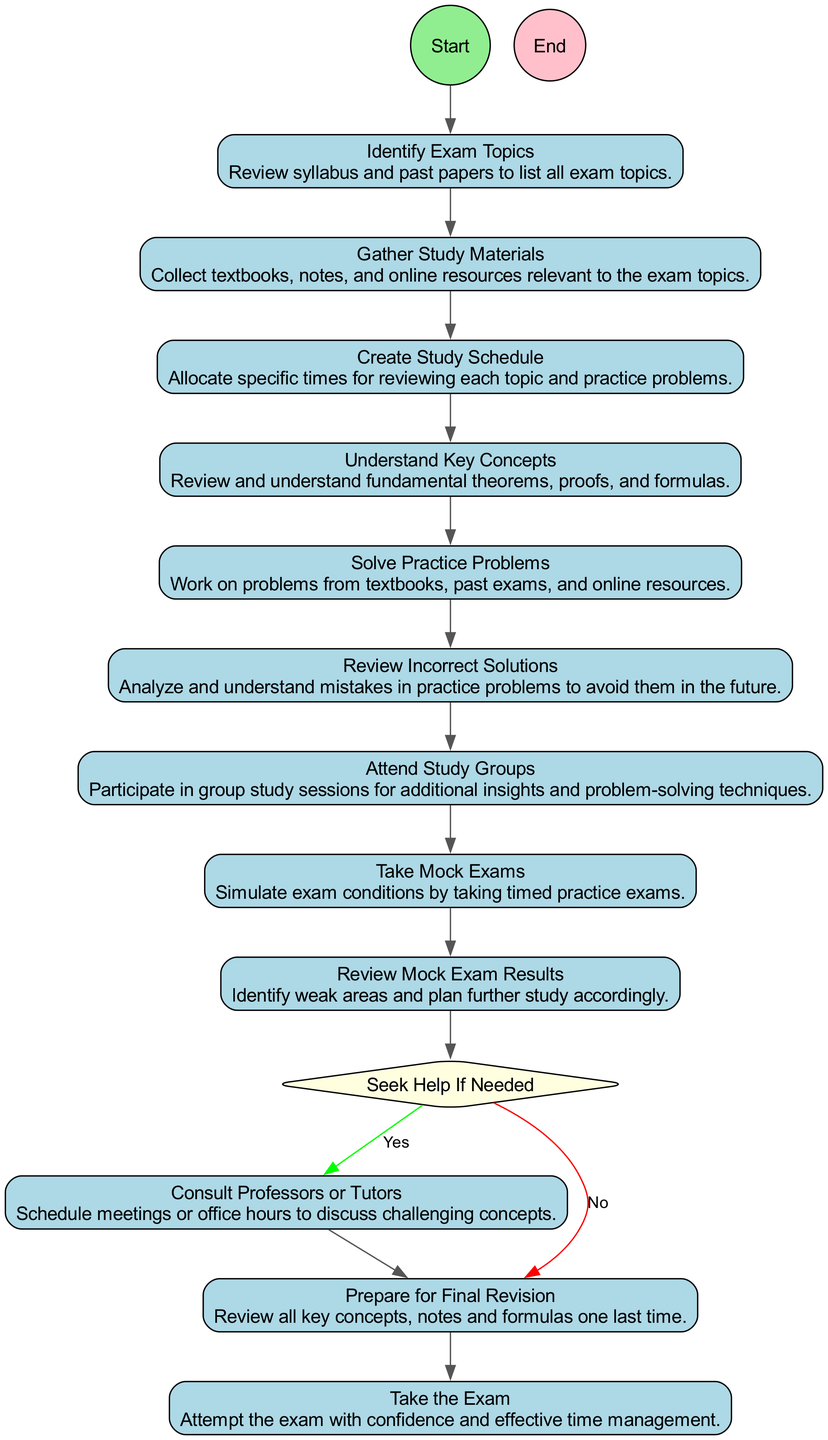What is the first activity in the diagram? The first activity is represented by the "Start" node, which leads to the next activity. The "Start" node indicates the beginning of the process and is followed by the described actions in the preparation for a geometry exam.
Answer: Identify Exam Topics How many total activities are there in the diagram? The diagram features activities as nodes between the start and end points, excluding the start and end nodes. Counting the "activity" nodes, there are 8 activities listed.
Answer: 8 What do you do after solving practice problems? After "Solve Practice Problems," the next activity is "Review Incorrect Solutions." This indicates that once practice problems are completed, reviewing mistakes is the subsequent step.
Answer: Review Incorrect Solutions What should you do if there are unresolved concepts or problems? If unresolved concepts are detected, the decision node indicates you should "Consult Professors or Tutors." If no issues are found, you should prepare for final revision.
Answer: Consult Professors or Tutors How many decision nodes are in the diagram? The diagram contains one decision node that directs the flow based on whether there are unresolved concepts, indicating a choice point in the study plan.
Answer: 1 What is the last activity before taking the exam? The last activity before reaching the end and taking the exam is "Prepare for Final Revision." This step comes after resolving any concepts and reviewing materials before the exam.
Answer: Prepare for Final Revision What do you review after taking mock exams? After taking mock exams, the next step is to "Review Mock Exam Results." This step involves analyzing performance to identify weak areas for further study.
Answer: Review Mock Exam Results What is the condition for seeking help? The condition specified in the decision node for seeking help is based on whether there are "unresolved concepts or problems." This guides the decision of consulting for assistance or proceeding to final revisions.
Answer: Are there any unresolved concepts or problems? 